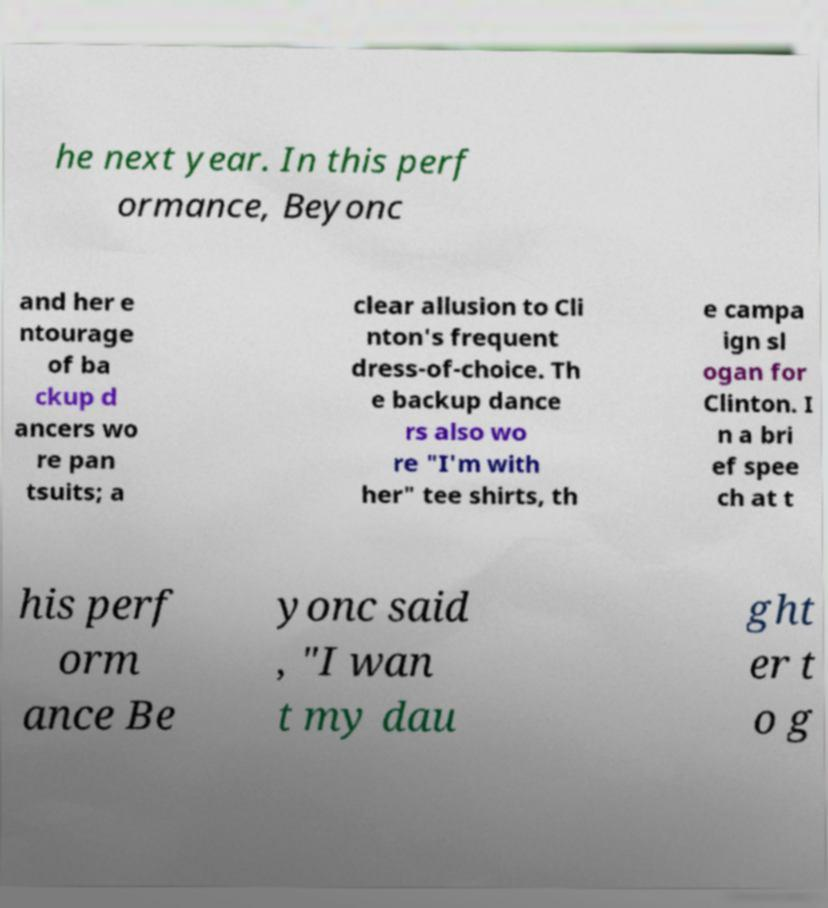Please identify and transcribe the text found in this image. he next year. In this perf ormance, Beyonc and her e ntourage of ba ckup d ancers wo re pan tsuits; a clear allusion to Cli nton's frequent dress-of-choice. Th e backup dance rs also wo re "I'm with her" tee shirts, th e campa ign sl ogan for Clinton. I n a bri ef spee ch at t his perf orm ance Be yonc said , "I wan t my dau ght er t o g 